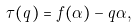<formula> <loc_0><loc_0><loc_500><loc_500>\tau ( q ) = f ( \alpha ) - q \alpha ,</formula> 